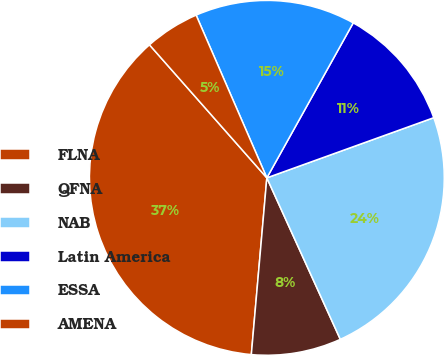Convert chart. <chart><loc_0><loc_0><loc_500><loc_500><pie_chart><fcel>FLNA<fcel>QFNA<fcel>NAB<fcel>Latin America<fcel>ESSA<fcel>AMENA<nl><fcel>37.1%<fcel>8.19%<fcel>23.71%<fcel>11.4%<fcel>14.62%<fcel>4.98%<nl></chart> 